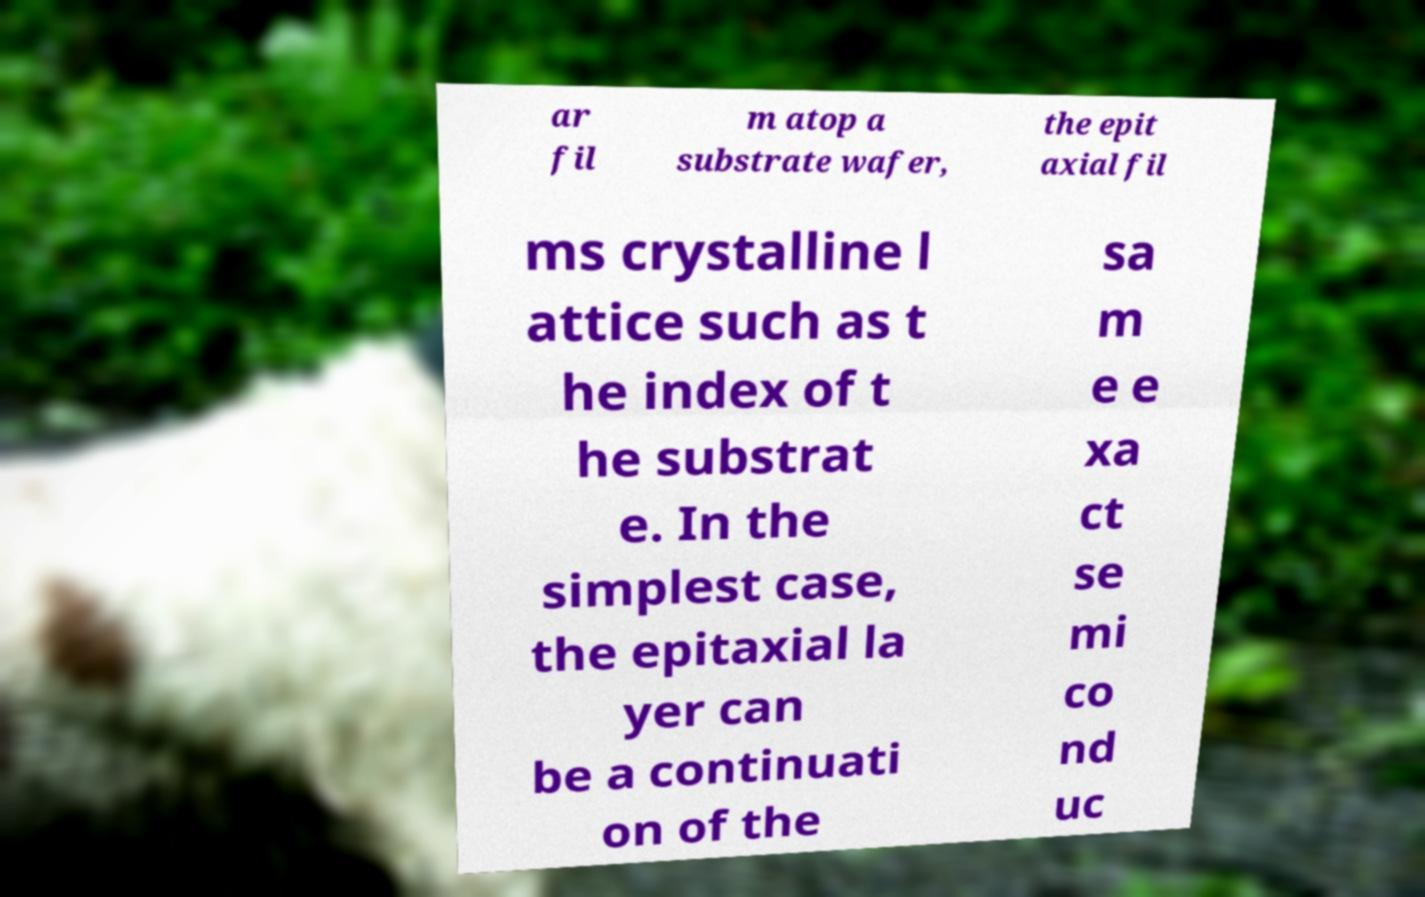There's text embedded in this image that I need extracted. Can you transcribe it verbatim? ar fil m atop a substrate wafer, the epit axial fil ms crystalline l attice such as t he index of t he substrat e. In the simplest case, the epitaxial la yer can be a continuati on of the sa m e e xa ct se mi co nd uc 